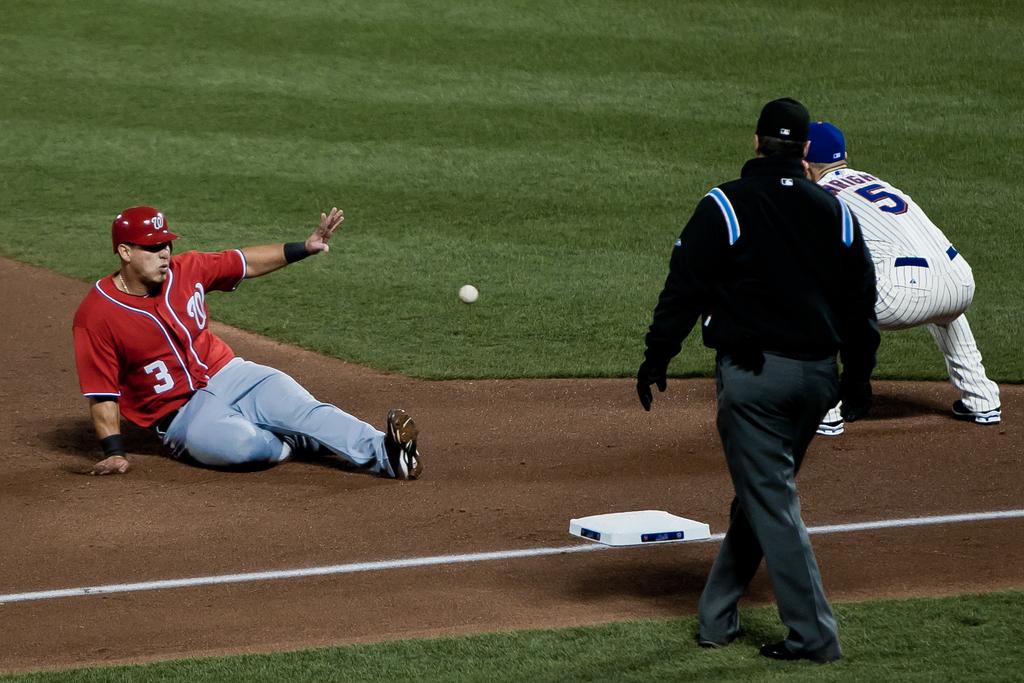What are these payers' numbers?
Your answer should be compact. 3 5. What lettter is on the shirt?
Keep it short and to the point. W. 